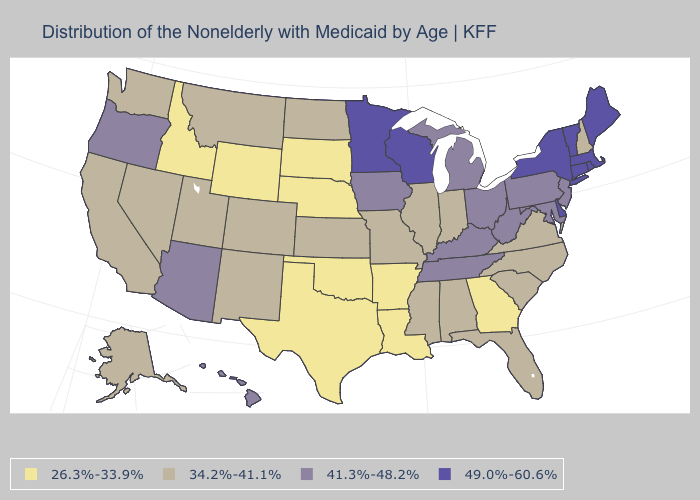Name the states that have a value in the range 26.3%-33.9%?
Short answer required. Arkansas, Georgia, Idaho, Louisiana, Nebraska, Oklahoma, South Dakota, Texas, Wyoming. Which states have the highest value in the USA?
Answer briefly. Connecticut, Delaware, Maine, Massachusetts, Minnesota, New York, Rhode Island, Vermont, Wisconsin. Name the states that have a value in the range 41.3%-48.2%?
Quick response, please. Arizona, Hawaii, Iowa, Kentucky, Maryland, Michigan, New Jersey, Ohio, Oregon, Pennsylvania, Tennessee, West Virginia. Which states hav the highest value in the MidWest?
Keep it brief. Minnesota, Wisconsin. Name the states that have a value in the range 26.3%-33.9%?
Give a very brief answer. Arkansas, Georgia, Idaho, Louisiana, Nebraska, Oklahoma, South Dakota, Texas, Wyoming. Does Maine have the lowest value in the Northeast?
Be succinct. No. What is the highest value in the Northeast ?
Write a very short answer. 49.0%-60.6%. Name the states that have a value in the range 49.0%-60.6%?
Quick response, please. Connecticut, Delaware, Maine, Massachusetts, Minnesota, New York, Rhode Island, Vermont, Wisconsin. Does New Hampshire have the lowest value in the Northeast?
Keep it brief. Yes. What is the value of Maryland?
Give a very brief answer. 41.3%-48.2%. Name the states that have a value in the range 41.3%-48.2%?
Concise answer only. Arizona, Hawaii, Iowa, Kentucky, Maryland, Michigan, New Jersey, Ohio, Oregon, Pennsylvania, Tennessee, West Virginia. Does Maine have the highest value in the USA?
Write a very short answer. Yes. What is the value of Alabama?
Concise answer only. 34.2%-41.1%. What is the highest value in the Northeast ?
Answer briefly. 49.0%-60.6%. What is the value of Washington?
Short answer required. 34.2%-41.1%. 